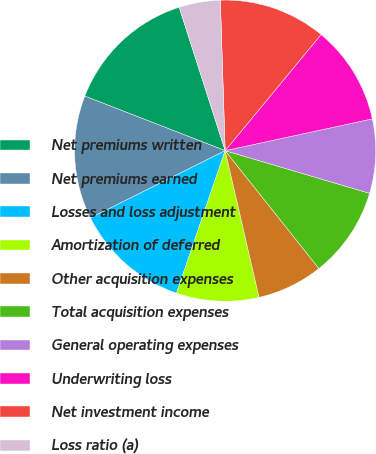<chart> <loc_0><loc_0><loc_500><loc_500><pie_chart><fcel>Net premiums written<fcel>Net premiums earned<fcel>Losses and loss adjustment<fcel>Amortization of deferred<fcel>Other acquisition expenses<fcel>Total acquisition expenses<fcel>General operating expenses<fcel>Underwriting loss<fcel>Net investment income<fcel>Loss ratio (a)<nl><fcel>14.16%<fcel>13.27%<fcel>12.39%<fcel>8.85%<fcel>7.08%<fcel>9.73%<fcel>7.96%<fcel>10.62%<fcel>11.5%<fcel>4.43%<nl></chart> 